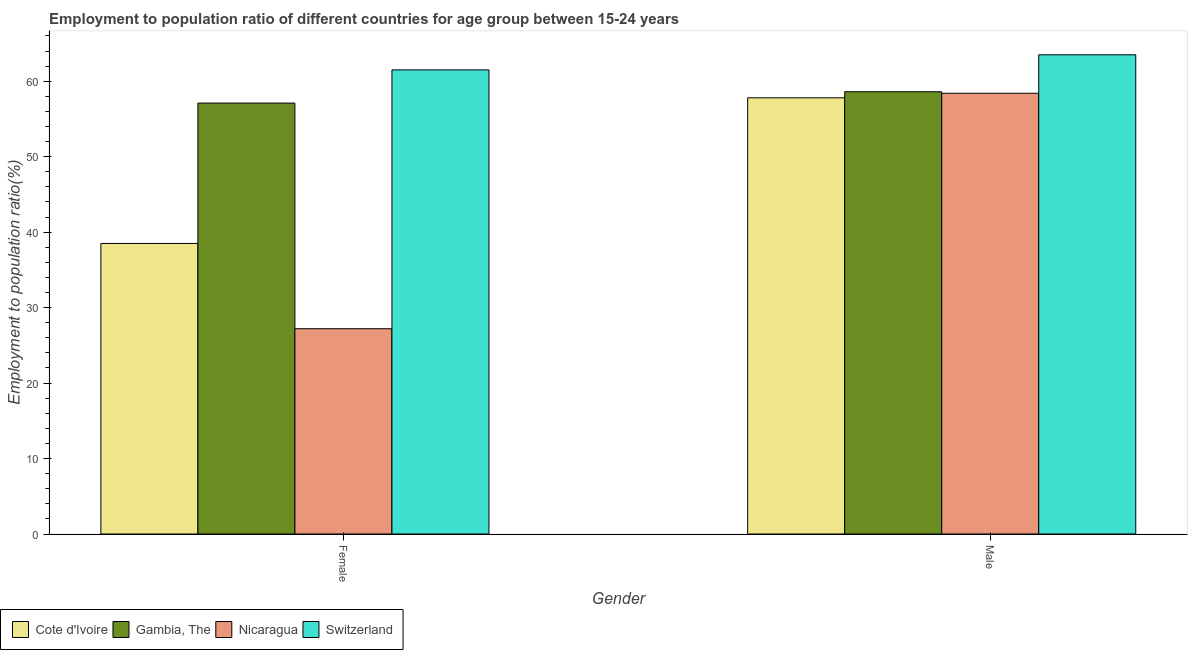How many different coloured bars are there?
Your answer should be compact. 4. How many bars are there on the 1st tick from the left?
Make the answer very short. 4. What is the label of the 1st group of bars from the left?
Make the answer very short. Female. What is the employment to population ratio(male) in Nicaragua?
Keep it short and to the point. 58.4. Across all countries, what is the maximum employment to population ratio(female)?
Provide a short and direct response. 61.5. Across all countries, what is the minimum employment to population ratio(male)?
Offer a very short reply. 57.8. In which country was the employment to population ratio(female) maximum?
Offer a terse response. Switzerland. In which country was the employment to population ratio(male) minimum?
Offer a very short reply. Cote d'Ivoire. What is the total employment to population ratio(male) in the graph?
Keep it short and to the point. 238.3. What is the difference between the employment to population ratio(male) in Cote d'Ivoire and that in Switzerland?
Provide a short and direct response. -5.7. What is the difference between the employment to population ratio(male) in Nicaragua and the employment to population ratio(female) in Switzerland?
Provide a short and direct response. -3.1. What is the average employment to population ratio(male) per country?
Provide a succinct answer. 59.57. What is the difference between the employment to population ratio(male) and employment to population ratio(female) in Nicaragua?
Your response must be concise. 31.2. In how many countries, is the employment to population ratio(male) greater than 14 %?
Make the answer very short. 4. What is the ratio of the employment to population ratio(male) in Cote d'Ivoire to that in Gambia, The?
Your response must be concise. 0.99. Is the employment to population ratio(male) in Switzerland less than that in Gambia, The?
Keep it short and to the point. No. In how many countries, is the employment to population ratio(female) greater than the average employment to population ratio(female) taken over all countries?
Your response must be concise. 2. What does the 3rd bar from the left in Female represents?
Make the answer very short. Nicaragua. What does the 2nd bar from the right in Male represents?
Make the answer very short. Nicaragua. How many bars are there?
Your answer should be compact. 8. Are all the bars in the graph horizontal?
Offer a very short reply. No. Does the graph contain any zero values?
Offer a very short reply. No. Does the graph contain grids?
Your answer should be very brief. No. Where does the legend appear in the graph?
Offer a terse response. Bottom left. How many legend labels are there?
Ensure brevity in your answer.  4. How are the legend labels stacked?
Offer a terse response. Horizontal. What is the title of the graph?
Ensure brevity in your answer.  Employment to population ratio of different countries for age group between 15-24 years. Does "Honduras" appear as one of the legend labels in the graph?
Make the answer very short. No. What is the label or title of the X-axis?
Your answer should be compact. Gender. What is the label or title of the Y-axis?
Give a very brief answer. Employment to population ratio(%). What is the Employment to population ratio(%) in Cote d'Ivoire in Female?
Your response must be concise. 38.5. What is the Employment to population ratio(%) of Gambia, The in Female?
Offer a very short reply. 57.1. What is the Employment to population ratio(%) of Nicaragua in Female?
Give a very brief answer. 27.2. What is the Employment to population ratio(%) in Switzerland in Female?
Give a very brief answer. 61.5. What is the Employment to population ratio(%) in Cote d'Ivoire in Male?
Give a very brief answer. 57.8. What is the Employment to population ratio(%) in Gambia, The in Male?
Your answer should be very brief. 58.6. What is the Employment to population ratio(%) in Nicaragua in Male?
Your answer should be very brief. 58.4. What is the Employment to population ratio(%) of Switzerland in Male?
Keep it short and to the point. 63.5. Across all Gender, what is the maximum Employment to population ratio(%) in Cote d'Ivoire?
Your answer should be very brief. 57.8. Across all Gender, what is the maximum Employment to population ratio(%) of Gambia, The?
Offer a terse response. 58.6. Across all Gender, what is the maximum Employment to population ratio(%) in Nicaragua?
Give a very brief answer. 58.4. Across all Gender, what is the maximum Employment to population ratio(%) in Switzerland?
Keep it short and to the point. 63.5. Across all Gender, what is the minimum Employment to population ratio(%) in Cote d'Ivoire?
Your response must be concise. 38.5. Across all Gender, what is the minimum Employment to population ratio(%) in Gambia, The?
Provide a short and direct response. 57.1. Across all Gender, what is the minimum Employment to population ratio(%) in Nicaragua?
Provide a succinct answer. 27.2. Across all Gender, what is the minimum Employment to population ratio(%) in Switzerland?
Your answer should be very brief. 61.5. What is the total Employment to population ratio(%) in Cote d'Ivoire in the graph?
Give a very brief answer. 96.3. What is the total Employment to population ratio(%) of Gambia, The in the graph?
Your answer should be very brief. 115.7. What is the total Employment to population ratio(%) in Nicaragua in the graph?
Keep it short and to the point. 85.6. What is the total Employment to population ratio(%) of Switzerland in the graph?
Your answer should be compact. 125. What is the difference between the Employment to population ratio(%) in Cote d'Ivoire in Female and that in Male?
Offer a very short reply. -19.3. What is the difference between the Employment to population ratio(%) in Nicaragua in Female and that in Male?
Your response must be concise. -31.2. What is the difference between the Employment to population ratio(%) in Cote d'Ivoire in Female and the Employment to population ratio(%) in Gambia, The in Male?
Your answer should be very brief. -20.1. What is the difference between the Employment to population ratio(%) in Cote d'Ivoire in Female and the Employment to population ratio(%) in Nicaragua in Male?
Offer a terse response. -19.9. What is the difference between the Employment to population ratio(%) in Nicaragua in Female and the Employment to population ratio(%) in Switzerland in Male?
Provide a succinct answer. -36.3. What is the average Employment to population ratio(%) of Cote d'Ivoire per Gender?
Provide a short and direct response. 48.15. What is the average Employment to population ratio(%) of Gambia, The per Gender?
Your answer should be compact. 57.85. What is the average Employment to population ratio(%) in Nicaragua per Gender?
Offer a very short reply. 42.8. What is the average Employment to population ratio(%) in Switzerland per Gender?
Give a very brief answer. 62.5. What is the difference between the Employment to population ratio(%) in Cote d'Ivoire and Employment to population ratio(%) in Gambia, The in Female?
Give a very brief answer. -18.6. What is the difference between the Employment to population ratio(%) of Cote d'Ivoire and Employment to population ratio(%) of Nicaragua in Female?
Provide a succinct answer. 11.3. What is the difference between the Employment to population ratio(%) in Gambia, The and Employment to population ratio(%) in Nicaragua in Female?
Provide a succinct answer. 29.9. What is the difference between the Employment to population ratio(%) in Nicaragua and Employment to population ratio(%) in Switzerland in Female?
Make the answer very short. -34.3. What is the difference between the Employment to population ratio(%) in Cote d'Ivoire and Employment to population ratio(%) in Gambia, The in Male?
Offer a very short reply. -0.8. What is the difference between the Employment to population ratio(%) in Cote d'Ivoire and Employment to population ratio(%) in Nicaragua in Male?
Offer a terse response. -0.6. What is the difference between the Employment to population ratio(%) of Gambia, The and Employment to population ratio(%) of Nicaragua in Male?
Keep it short and to the point. 0.2. What is the ratio of the Employment to population ratio(%) in Cote d'Ivoire in Female to that in Male?
Your answer should be very brief. 0.67. What is the ratio of the Employment to population ratio(%) in Gambia, The in Female to that in Male?
Your answer should be compact. 0.97. What is the ratio of the Employment to population ratio(%) of Nicaragua in Female to that in Male?
Offer a very short reply. 0.47. What is the ratio of the Employment to population ratio(%) in Switzerland in Female to that in Male?
Your response must be concise. 0.97. What is the difference between the highest and the second highest Employment to population ratio(%) in Cote d'Ivoire?
Ensure brevity in your answer.  19.3. What is the difference between the highest and the second highest Employment to population ratio(%) in Gambia, The?
Offer a terse response. 1.5. What is the difference between the highest and the second highest Employment to population ratio(%) in Nicaragua?
Your answer should be compact. 31.2. What is the difference between the highest and the second highest Employment to population ratio(%) of Switzerland?
Your answer should be very brief. 2. What is the difference between the highest and the lowest Employment to population ratio(%) of Cote d'Ivoire?
Offer a terse response. 19.3. What is the difference between the highest and the lowest Employment to population ratio(%) of Nicaragua?
Give a very brief answer. 31.2. What is the difference between the highest and the lowest Employment to population ratio(%) in Switzerland?
Ensure brevity in your answer.  2. 